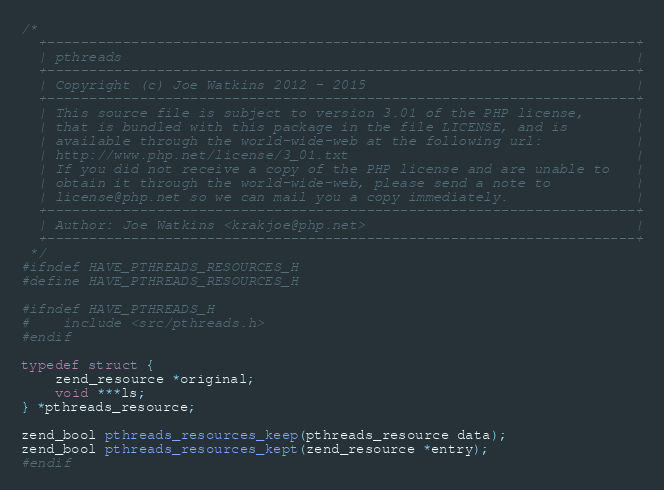Convert code to text. <code><loc_0><loc_0><loc_500><loc_500><_C_>/*
  +----------------------------------------------------------------------+
  | pthreads                                                             |
  +----------------------------------------------------------------------+
  | Copyright (c) Joe Watkins 2012 - 2015                                |
  +----------------------------------------------------------------------+
  | This source file is subject to version 3.01 of the PHP license,      |
  | that is bundled with this package in the file LICENSE, and is        |
  | available through the world-wide-web at the following url:           |
  | http://www.php.net/license/3_01.txt                                  |
  | If you did not receive a copy of the PHP license and are unable to   |
  | obtain it through the world-wide-web, please send a note to          |
  | license@php.net so we can mail you a copy immediately.               |
  +----------------------------------------------------------------------+
  | Author: Joe Watkins <krakjoe@php.net>                                |
  +----------------------------------------------------------------------+
 */
#ifndef HAVE_PTHREADS_RESOURCES_H
#define HAVE_PTHREADS_RESOURCES_H

#ifndef HAVE_PTHREADS_H
#	include <src/pthreads.h>
#endif

typedef struct {
	zend_resource *original;
	void ***ls;
} *pthreads_resource;

zend_bool pthreads_resources_keep(pthreads_resource data);
zend_bool pthreads_resources_kept(zend_resource *entry);
#endif

</code> 